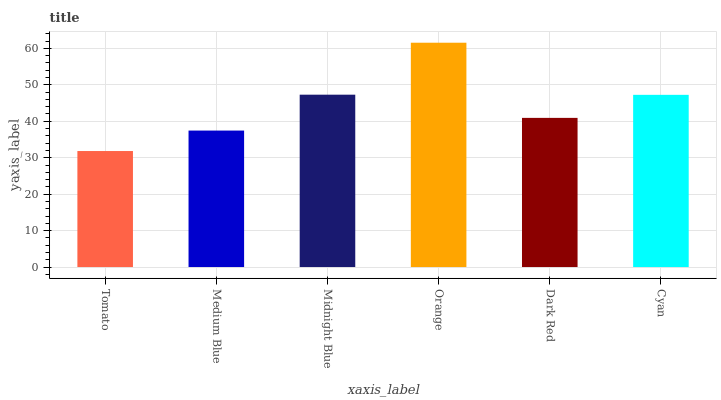Is Tomato the minimum?
Answer yes or no. Yes. Is Orange the maximum?
Answer yes or no. Yes. Is Medium Blue the minimum?
Answer yes or no. No. Is Medium Blue the maximum?
Answer yes or no. No. Is Medium Blue greater than Tomato?
Answer yes or no. Yes. Is Tomato less than Medium Blue?
Answer yes or no. Yes. Is Tomato greater than Medium Blue?
Answer yes or no. No. Is Medium Blue less than Tomato?
Answer yes or no. No. Is Cyan the high median?
Answer yes or no. Yes. Is Dark Red the low median?
Answer yes or no. Yes. Is Midnight Blue the high median?
Answer yes or no. No. Is Orange the low median?
Answer yes or no. No. 